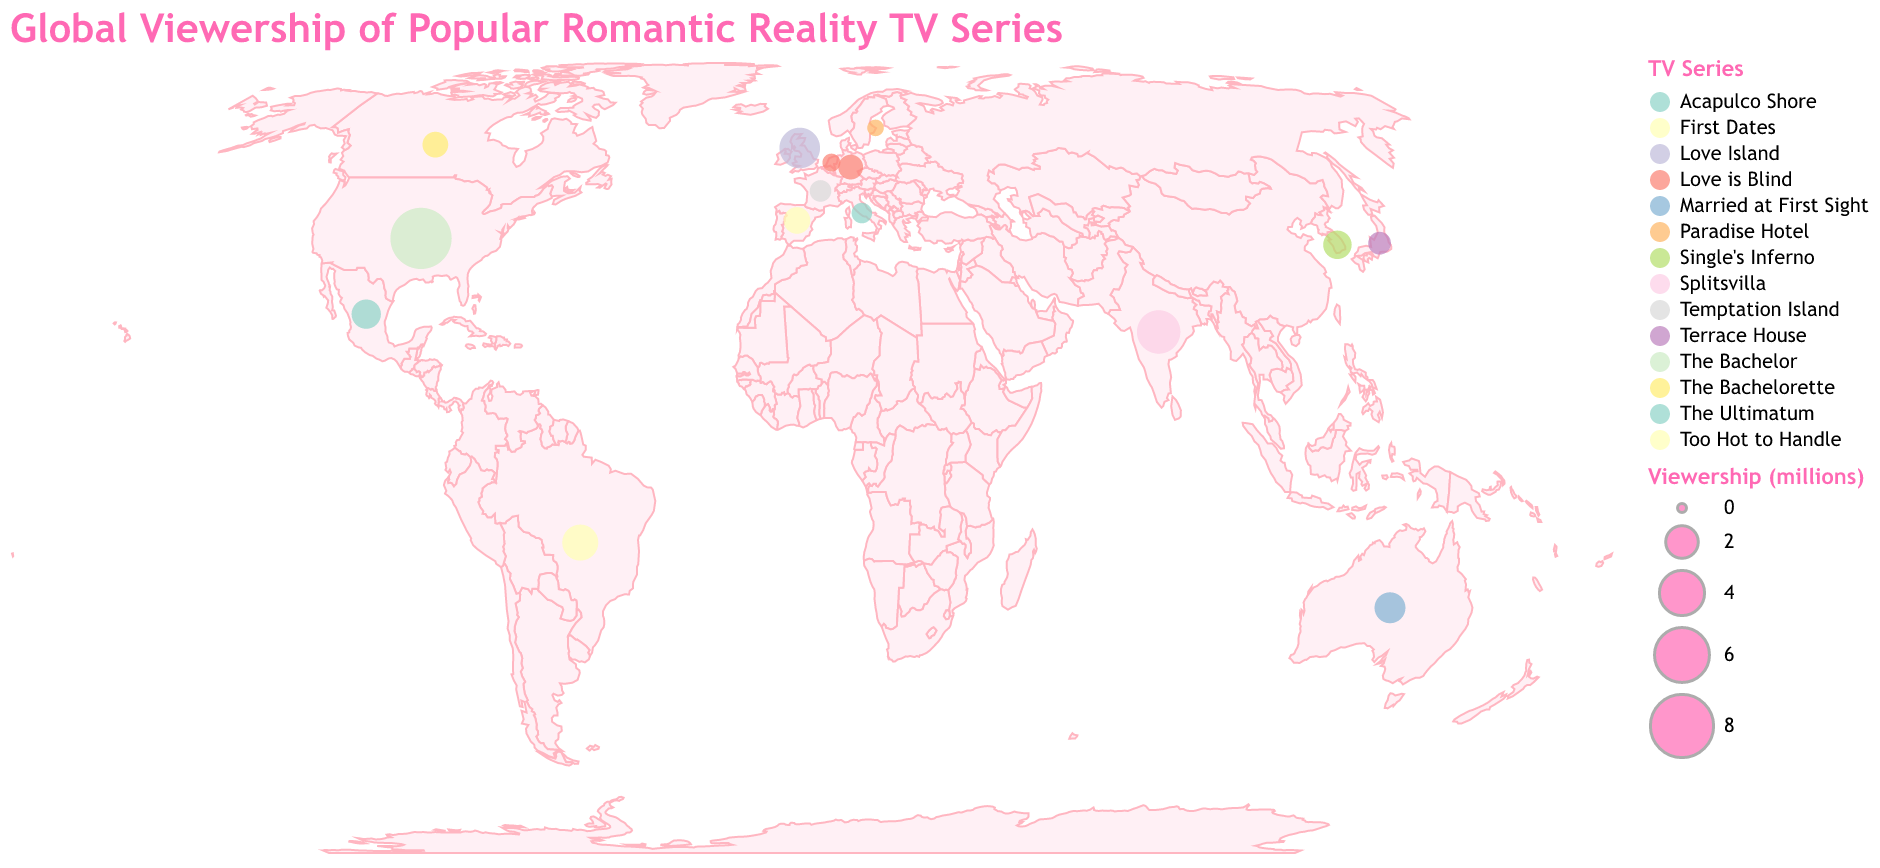Which country has the highest viewership for a romantic reality TV series? The largest circle on the map, indicating the highest viewership, is located in the United States for "The Bachelor" with a viewership of 7.5 million.
Answer: United States Which series has the lowest viewership in the displayed data? The smallest circle on the map represents "Paradise Hotel" in Sweden, with a viewership of 0.4 million.
Answer: Paradise Hotel How does the viewership of "Splitsvilla" in India compare to "Love Island" in the United Kingdom? Comparing the size of circles, "Splitsvilla" in India has a higher viewership (3.7 million) than "Love Island" in the United Kingdom (3.2 million).
Answer: Splitsvilla has more viewership What is the average viewership for series in countries with viewership above 2 million? Countries above 2 million viewership are the United States (7.5), United Kingdom (3.2), Brazil (2.5), and India (3.7). Average viewership = (7.5 + 3.2 + 2.5 + 3.7) / 4 = 4.225 million.
Answer: 4.225 million Which series is popular across multiple countries? "Love is Blind" is displayed in both Germany and the Netherlands.
Answer: Love is Blind What is the total viewership of the series in the Americas (United States, Brazil, Canada, and Mexico)? United States (7.5), Brazil (2.5), Canada (1.2), Mexico (1.6). Total viewership = 7.5 + 2.5 + 1.2 + 1.6 = 12.8 million.
Answer: 12.8 million What is the ratio of viewership between “The Bachelor” in the United States and “Single's Inferno” in South Korea? The viewership is 7.5 million for "The Bachelor" and 1.5 million for "Single's Inferno". The ratio is 7.5 / 1.5 = 5.
Answer: 5 Which continent has the most diverse range of popular series? By observing the plot, Europe has the highest diversity with five series: "Love Island" (UK), "Too Hot to Handle" (Brazil), "Love is Blind" (Germany, Netherlands), "Temptation Island" (France), and "First Dates" (Spain).
Answer: Europe What series has the viewership closest to 1 million? "Love is Blind" in Germany and "Terrace House" in Japan have viewerships near 1 million, with 1.1 and 0.9 million respectively. "Love is Blind" is closer to 1 million.
Answer: Love is Blind 